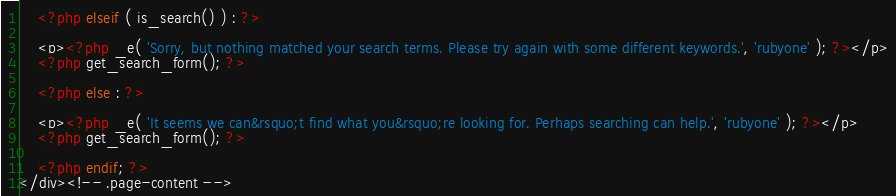Convert code to text. <code><loc_0><loc_0><loc_500><loc_500><_PHP_>
	<?php elseif ( is_search() ) : ?>

	<p><?php _e( 'Sorry, but nothing matched your search terms. Please try again with some different keywords.', 'rubyone' ); ?></p>
	<?php get_search_form(); ?>

	<?php else : ?>

	<p><?php _e( 'It seems we can&rsquo;t find what you&rsquo;re looking for. Perhaps searching can help.', 'rubyone' ); ?></p>
	<?php get_search_form(); ?>

	<?php endif; ?>
</div><!-- .page-content -->
</code> 